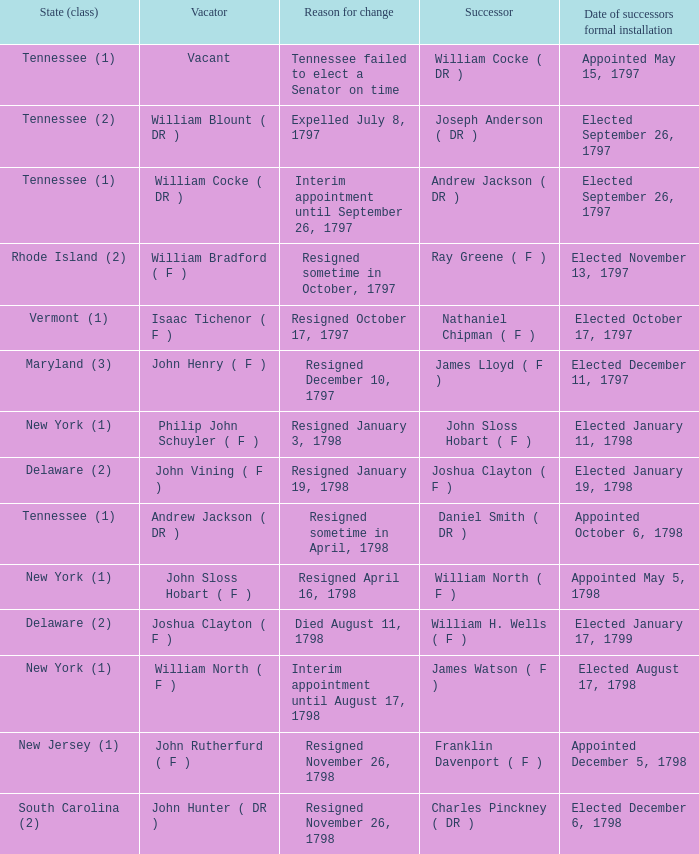What is the entire sum of dates for successor formal initiation when the outgoing individual was joshua clayton (f)? 1.0. 